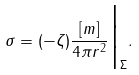<formula> <loc_0><loc_0><loc_500><loc_500>\sigma = ( - \zeta ) \frac { [ m ] } { 4 \pi r ^ { 2 } } \Big | _ { \Sigma } .</formula> 